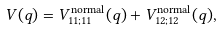<formula> <loc_0><loc_0><loc_500><loc_500>V ( q ) = V ^ { \text {normal} } _ { 1 1 ; 1 1 } ( q ) + V ^ { \text {normal} } _ { 1 2 ; 1 2 } ( q ) ,</formula> 